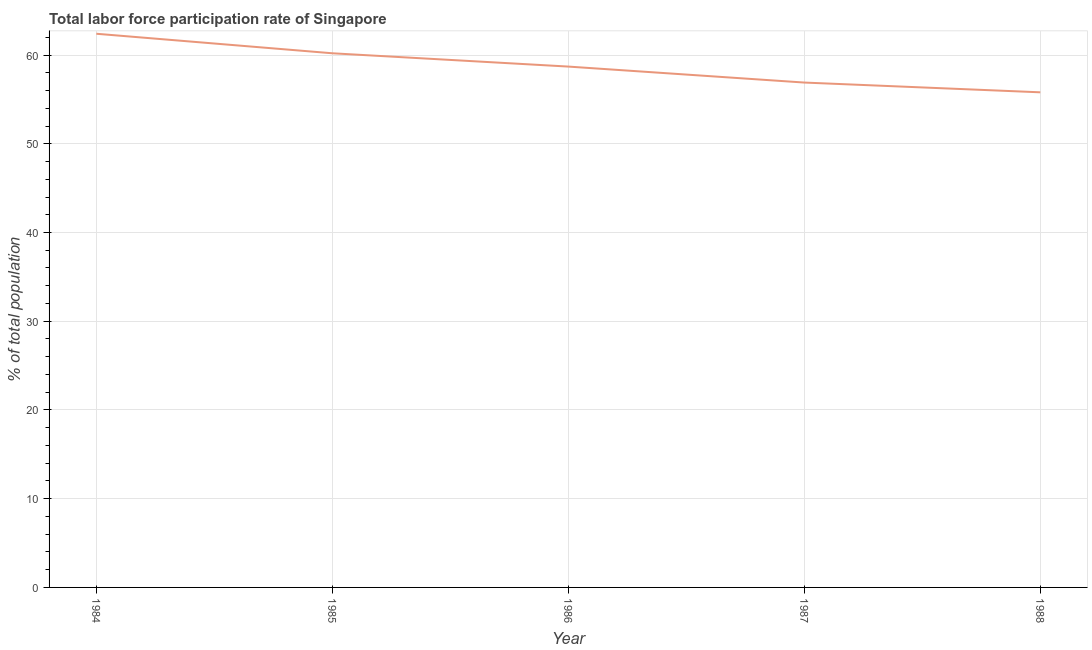What is the total labor force participation rate in 1986?
Provide a short and direct response. 58.7. Across all years, what is the maximum total labor force participation rate?
Provide a succinct answer. 62.4. Across all years, what is the minimum total labor force participation rate?
Your answer should be compact. 55.8. What is the sum of the total labor force participation rate?
Your answer should be compact. 294. What is the difference between the total labor force participation rate in 1986 and 1988?
Your answer should be very brief. 2.9. What is the average total labor force participation rate per year?
Keep it short and to the point. 58.8. What is the median total labor force participation rate?
Provide a short and direct response. 58.7. In how many years, is the total labor force participation rate greater than 24 %?
Your response must be concise. 5. What is the ratio of the total labor force participation rate in 1985 to that in 1988?
Ensure brevity in your answer.  1.08. Is the total labor force participation rate in 1985 less than that in 1986?
Keep it short and to the point. No. What is the difference between the highest and the second highest total labor force participation rate?
Provide a succinct answer. 2.2. What is the difference between the highest and the lowest total labor force participation rate?
Your response must be concise. 6.6. How many lines are there?
Keep it short and to the point. 1. What is the difference between two consecutive major ticks on the Y-axis?
Provide a succinct answer. 10. Are the values on the major ticks of Y-axis written in scientific E-notation?
Your response must be concise. No. Does the graph contain any zero values?
Your response must be concise. No. What is the title of the graph?
Give a very brief answer. Total labor force participation rate of Singapore. What is the label or title of the X-axis?
Your response must be concise. Year. What is the label or title of the Y-axis?
Provide a short and direct response. % of total population. What is the % of total population in 1984?
Give a very brief answer. 62.4. What is the % of total population in 1985?
Keep it short and to the point. 60.2. What is the % of total population of 1986?
Give a very brief answer. 58.7. What is the % of total population of 1987?
Provide a short and direct response. 56.9. What is the % of total population of 1988?
Your response must be concise. 55.8. What is the difference between the % of total population in 1984 and 1987?
Provide a short and direct response. 5.5. What is the difference between the % of total population in 1984 and 1988?
Your answer should be compact. 6.6. What is the difference between the % of total population in 1985 and 1987?
Provide a succinct answer. 3.3. What is the difference between the % of total population in 1986 and 1988?
Ensure brevity in your answer.  2.9. What is the ratio of the % of total population in 1984 to that in 1985?
Offer a very short reply. 1.04. What is the ratio of the % of total population in 1984 to that in 1986?
Your answer should be very brief. 1.06. What is the ratio of the % of total population in 1984 to that in 1987?
Your response must be concise. 1.1. What is the ratio of the % of total population in 1984 to that in 1988?
Offer a very short reply. 1.12. What is the ratio of the % of total population in 1985 to that in 1986?
Offer a very short reply. 1.03. What is the ratio of the % of total population in 1985 to that in 1987?
Keep it short and to the point. 1.06. What is the ratio of the % of total population in 1985 to that in 1988?
Provide a succinct answer. 1.08. What is the ratio of the % of total population in 1986 to that in 1987?
Keep it short and to the point. 1.03. What is the ratio of the % of total population in 1986 to that in 1988?
Provide a succinct answer. 1.05. 